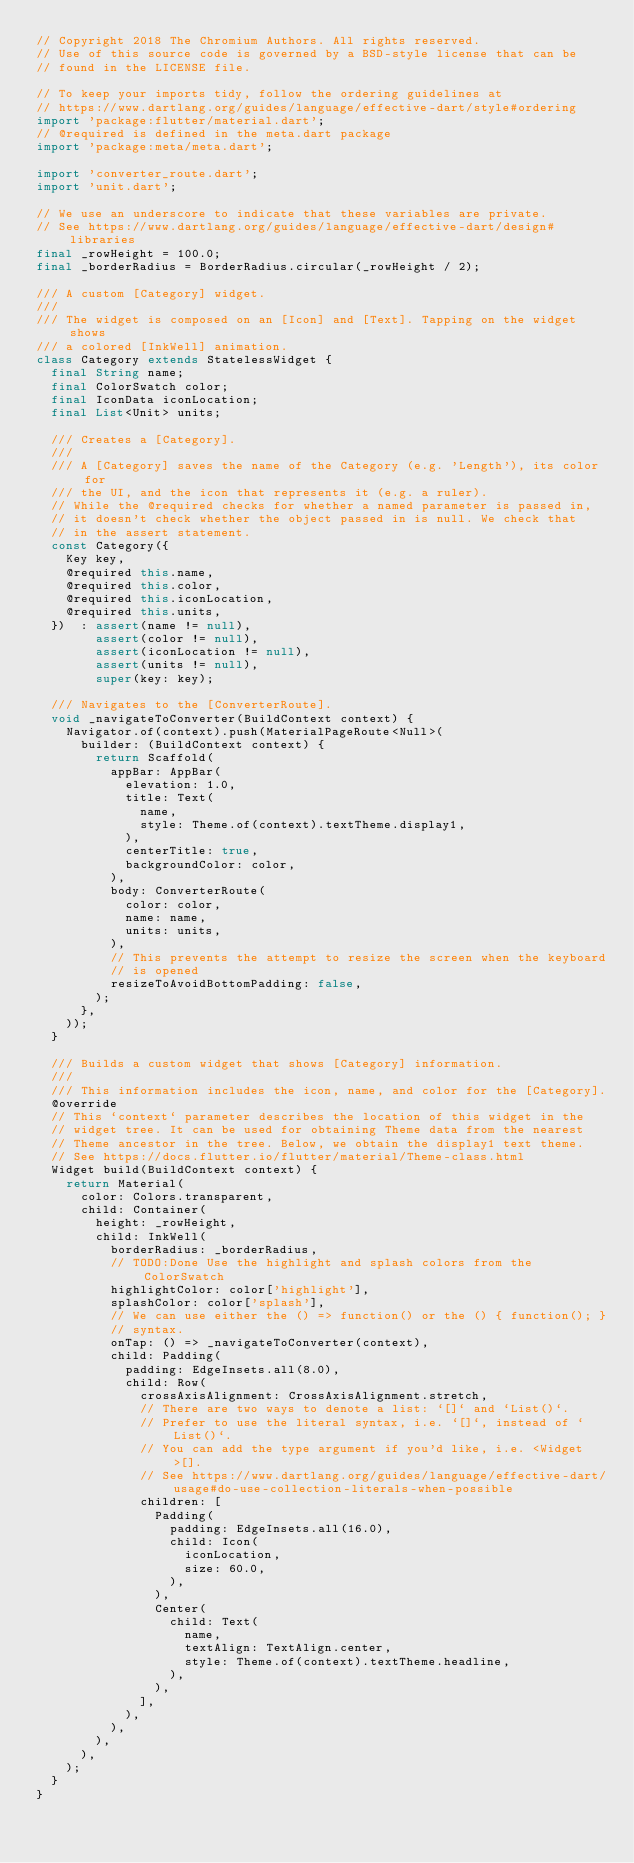<code> <loc_0><loc_0><loc_500><loc_500><_Dart_>// Copyright 2018 The Chromium Authors. All rights reserved.
// Use of this source code is governed by a BSD-style license that can be
// found in the LICENSE file.

// To keep your imports tidy, follow the ordering guidelines at
// https://www.dartlang.org/guides/language/effective-dart/style#ordering
import 'package:flutter/material.dart';
// @required is defined in the meta.dart package
import 'package:meta/meta.dart';

import 'converter_route.dart';
import 'unit.dart';

// We use an underscore to indicate that these variables are private.
// See https://www.dartlang.org/guides/language/effective-dart/design#libraries
final _rowHeight = 100.0;
final _borderRadius = BorderRadius.circular(_rowHeight / 2);

/// A custom [Category] widget.
///
/// The widget is composed on an [Icon] and [Text]. Tapping on the widget shows
/// a colored [InkWell] animation.
class Category extends StatelessWidget {
  final String name;
  final ColorSwatch color;
  final IconData iconLocation;
  final List<Unit> units;

  /// Creates a [Category].
  ///
  /// A [Category] saves the name of the Category (e.g. 'Length'), its color for
  /// the UI, and the icon that represents it (e.g. a ruler).
  // While the @required checks for whether a named parameter is passed in,
  // it doesn't check whether the object passed in is null. We check that
  // in the assert statement.
  const Category({
    Key key,
    @required this.name,
    @required this.color,
    @required this.iconLocation,
    @required this.units,
  })  : assert(name != null),
        assert(color != null),
        assert(iconLocation != null),
        assert(units != null),
        super(key: key);

  /// Navigates to the [ConverterRoute].
  void _navigateToConverter(BuildContext context) {
    Navigator.of(context).push(MaterialPageRoute<Null>(
      builder: (BuildContext context) {
        return Scaffold(
          appBar: AppBar(
            elevation: 1.0,
            title: Text(
              name,
              style: Theme.of(context).textTheme.display1,
            ),
            centerTitle: true,
            backgroundColor: color,
          ),
          body: ConverterRoute(
            color: color,
            name: name,
            units: units,
          ),
          // This prevents the attempt to resize the screen when the keyboard
          // is opened
          resizeToAvoidBottomPadding: false,
        );
      },
    ));
  }

  /// Builds a custom widget that shows [Category] information.
  ///
  /// This information includes the icon, name, and color for the [Category].
  @override
  // This `context` parameter describes the location of this widget in the
  // widget tree. It can be used for obtaining Theme data from the nearest
  // Theme ancestor in the tree. Below, we obtain the display1 text theme.
  // See https://docs.flutter.io/flutter/material/Theme-class.html
  Widget build(BuildContext context) {
    return Material(
      color: Colors.transparent,
      child: Container(
        height: _rowHeight,
        child: InkWell(
          borderRadius: _borderRadius,
          // TODO:Done Use the highlight and splash colors from the ColorSwatch
          highlightColor: color['highlight'],
          splashColor: color['splash'],
          // We can use either the () => function() or the () { function(); }
          // syntax.
          onTap: () => _navigateToConverter(context),
          child: Padding(
            padding: EdgeInsets.all(8.0),
            child: Row(
              crossAxisAlignment: CrossAxisAlignment.stretch,
              // There are two ways to denote a list: `[]` and `List()`.
              // Prefer to use the literal syntax, i.e. `[]`, instead of `List()`.
              // You can add the type argument if you'd like, i.e. <Widget>[].
              // See https://www.dartlang.org/guides/language/effective-dart/usage#do-use-collection-literals-when-possible
              children: [
                Padding(
                  padding: EdgeInsets.all(16.0),
                  child: Icon(
                    iconLocation,
                    size: 60.0,
                  ),
                ),
                Center(
                  child: Text(
                    name,
                    textAlign: TextAlign.center,
                    style: Theme.of(context).textTheme.headline,
                  ),
                ),
              ],
            ),
          ),
        ),
      ),
    );
  }
}
</code> 